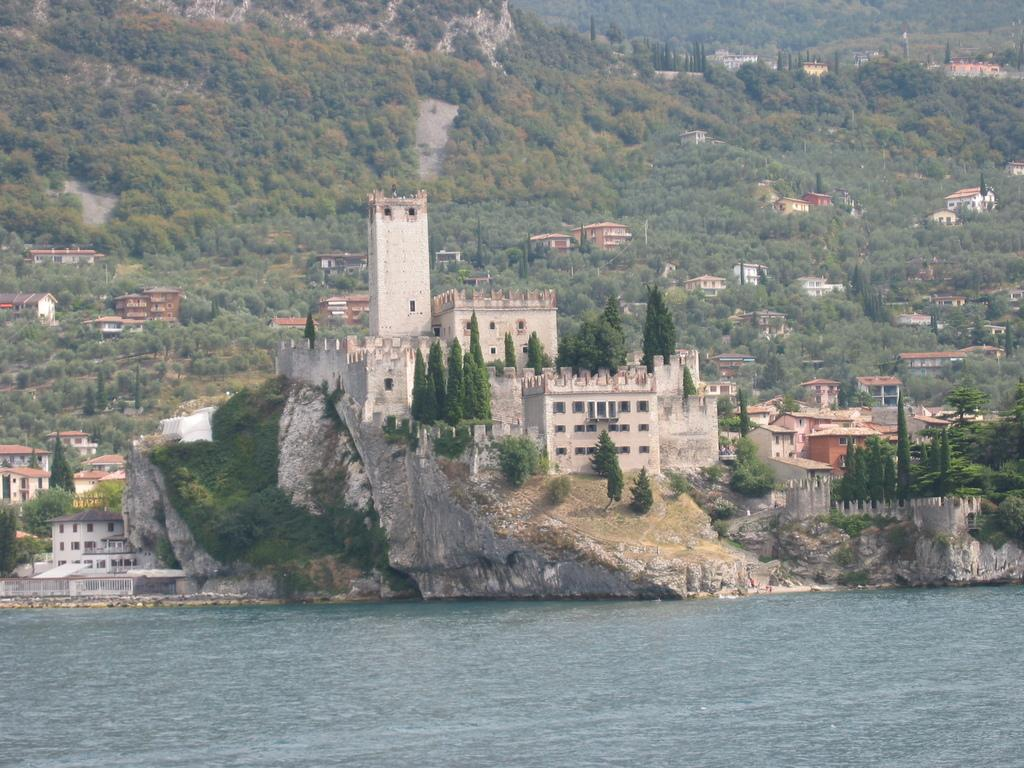What type of structures can be seen in the image? There are buildings in the image. What natural elements are present in the image? There are trees and rocks in the image. What can be seen in the background of the image? There is water visible in the image. How many grapes are hanging from the trees in the image? There are no grapes present in the image; it features trees, buildings, rocks, and water. Can you describe the behavior of the dogs in the image? There are no dogs present in the image. 